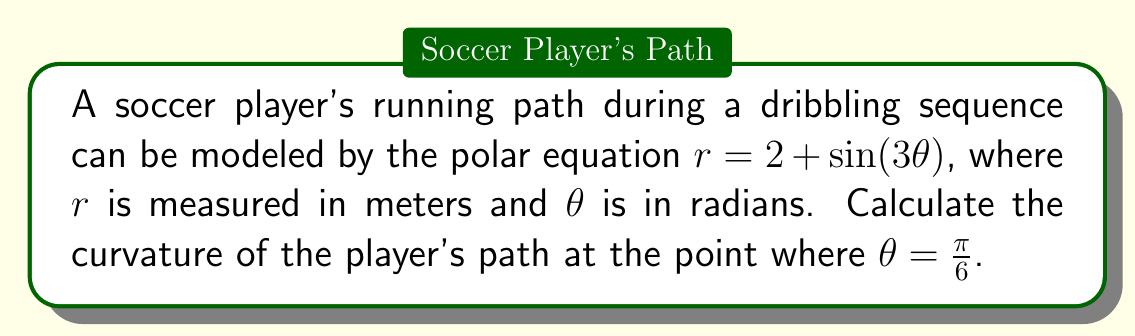Show me your answer to this math problem. To analyze the curvature of the player's running path, we'll use the formula for curvature in polar coordinates:

$$\kappa = \frac{|r^2 + 2(r')^2 - rr''|}{(r^2 + (r')^2)^{3/2}}$$

Where $r' = \frac{dr}{d\theta}$ and $r'' = \frac{d^2r}{d\theta^2}$.

Step 1: Find $r$, $r'$, and $r''$
$r = 2 + \sin(3\theta)$
$r' = 3\cos(3\theta)$
$r'' = -9\sin(3\theta)$

Step 2: Evaluate $r$, $r'$, and $r''$ at $\theta = \frac{\pi}{6}$
$r(\frac{\pi}{6}) = 2 + \sin(\frac{\pi}{2}) = 2 + 1 = 3$
$r'(\frac{\pi}{6}) = 3\cos(\frac{\pi}{2}) = 0$
$r''(\frac{\pi}{6}) = -9\sin(\frac{\pi}{2}) = -9$

Step 3: Substitute these values into the curvature formula
$$\kappa = \frac{|3^2 + 2(0)^2 - 3(-9)|}{(3^2 + 0^2)^{3/2}}$$

Step 4: Simplify and calculate
$$\kappa = \frac{|9 + 27|}{27} = \frac{36}{27} = \frac{4}{3}$$

Therefore, the curvature of the player's path at $\theta = \frac{\pi}{6}$ is $\frac{4}{3}$ m⁻¹.
Answer: $\frac{4}{3}$ m⁻¹ 